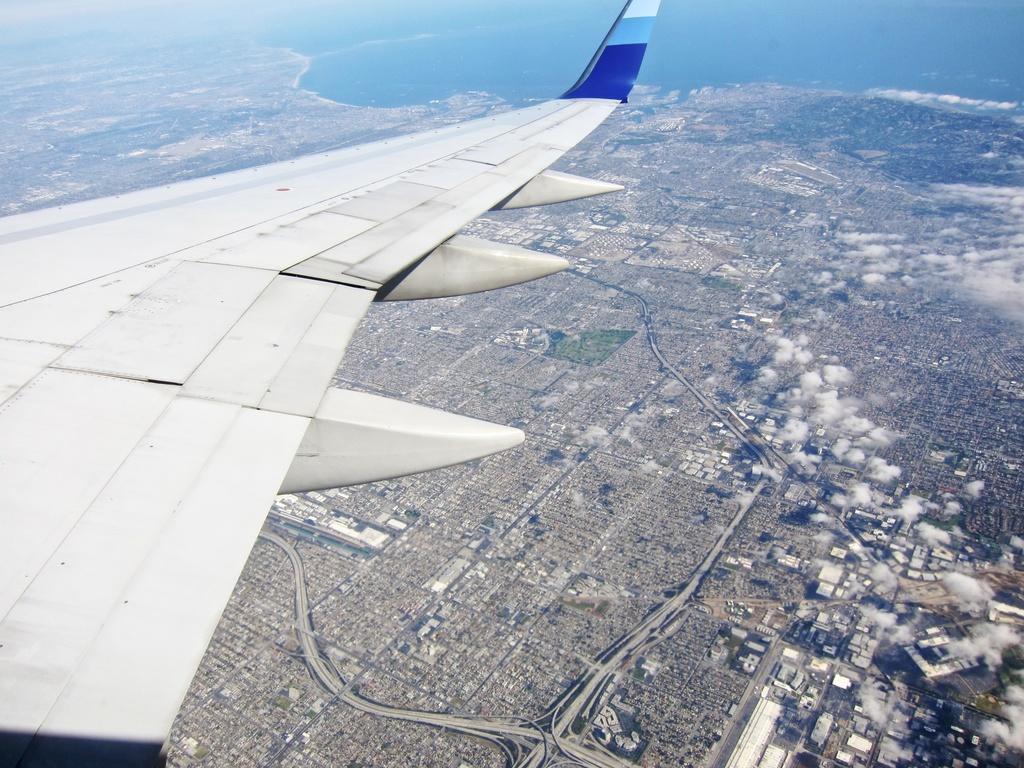How would you summarize this image in a sentence or two? In this image we can see an airplane wing in the air. In the background, we can see the sky and water. 